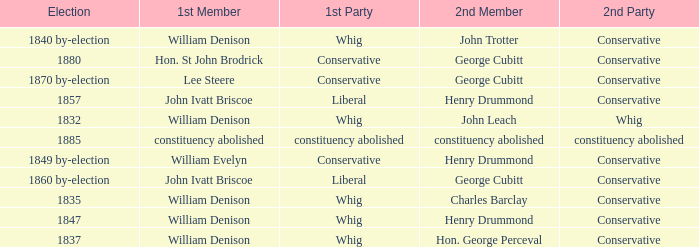Which party's 1st member is William Denison in the election of 1832? Whig. 